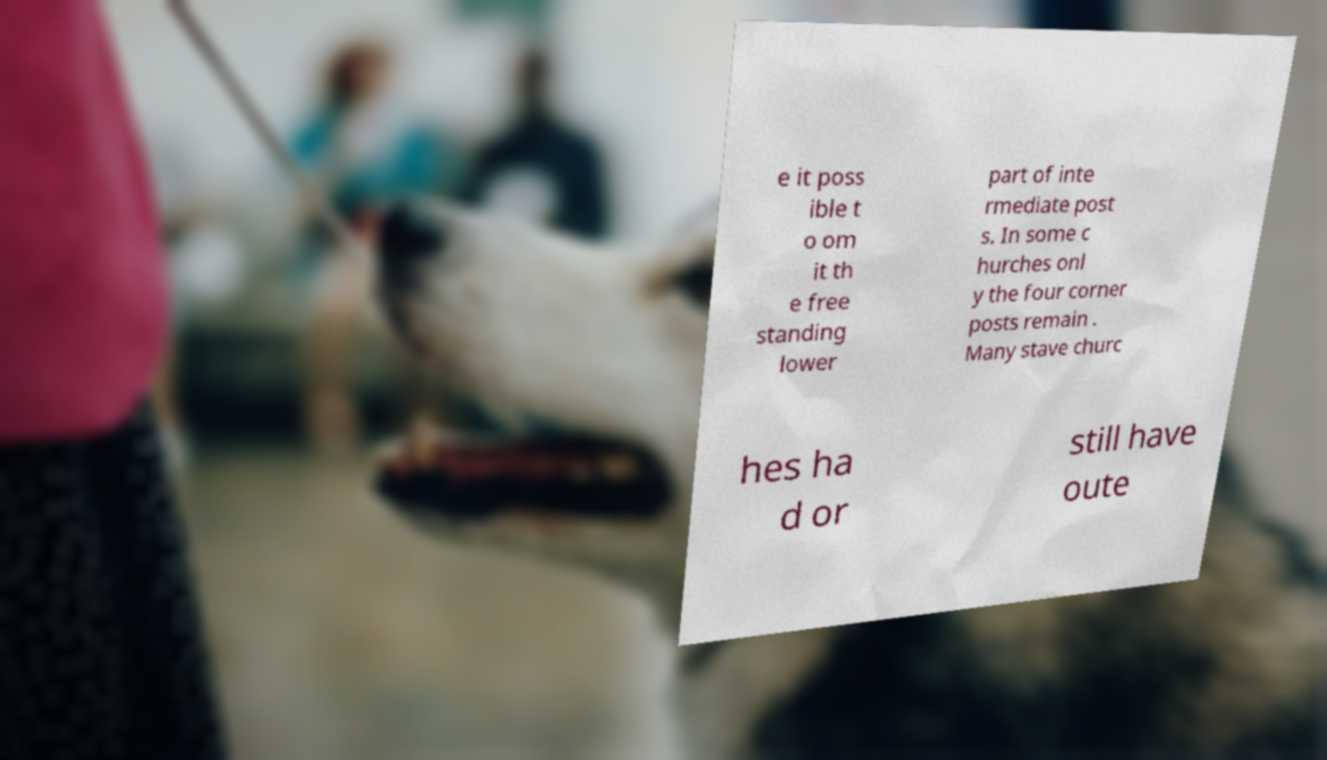Can you read and provide the text displayed in the image?This photo seems to have some interesting text. Can you extract and type it out for me? e it poss ible t o om it th e free standing lower part of inte rmediate post s. In some c hurches onl y the four corner posts remain . Many stave churc hes ha d or still have oute 